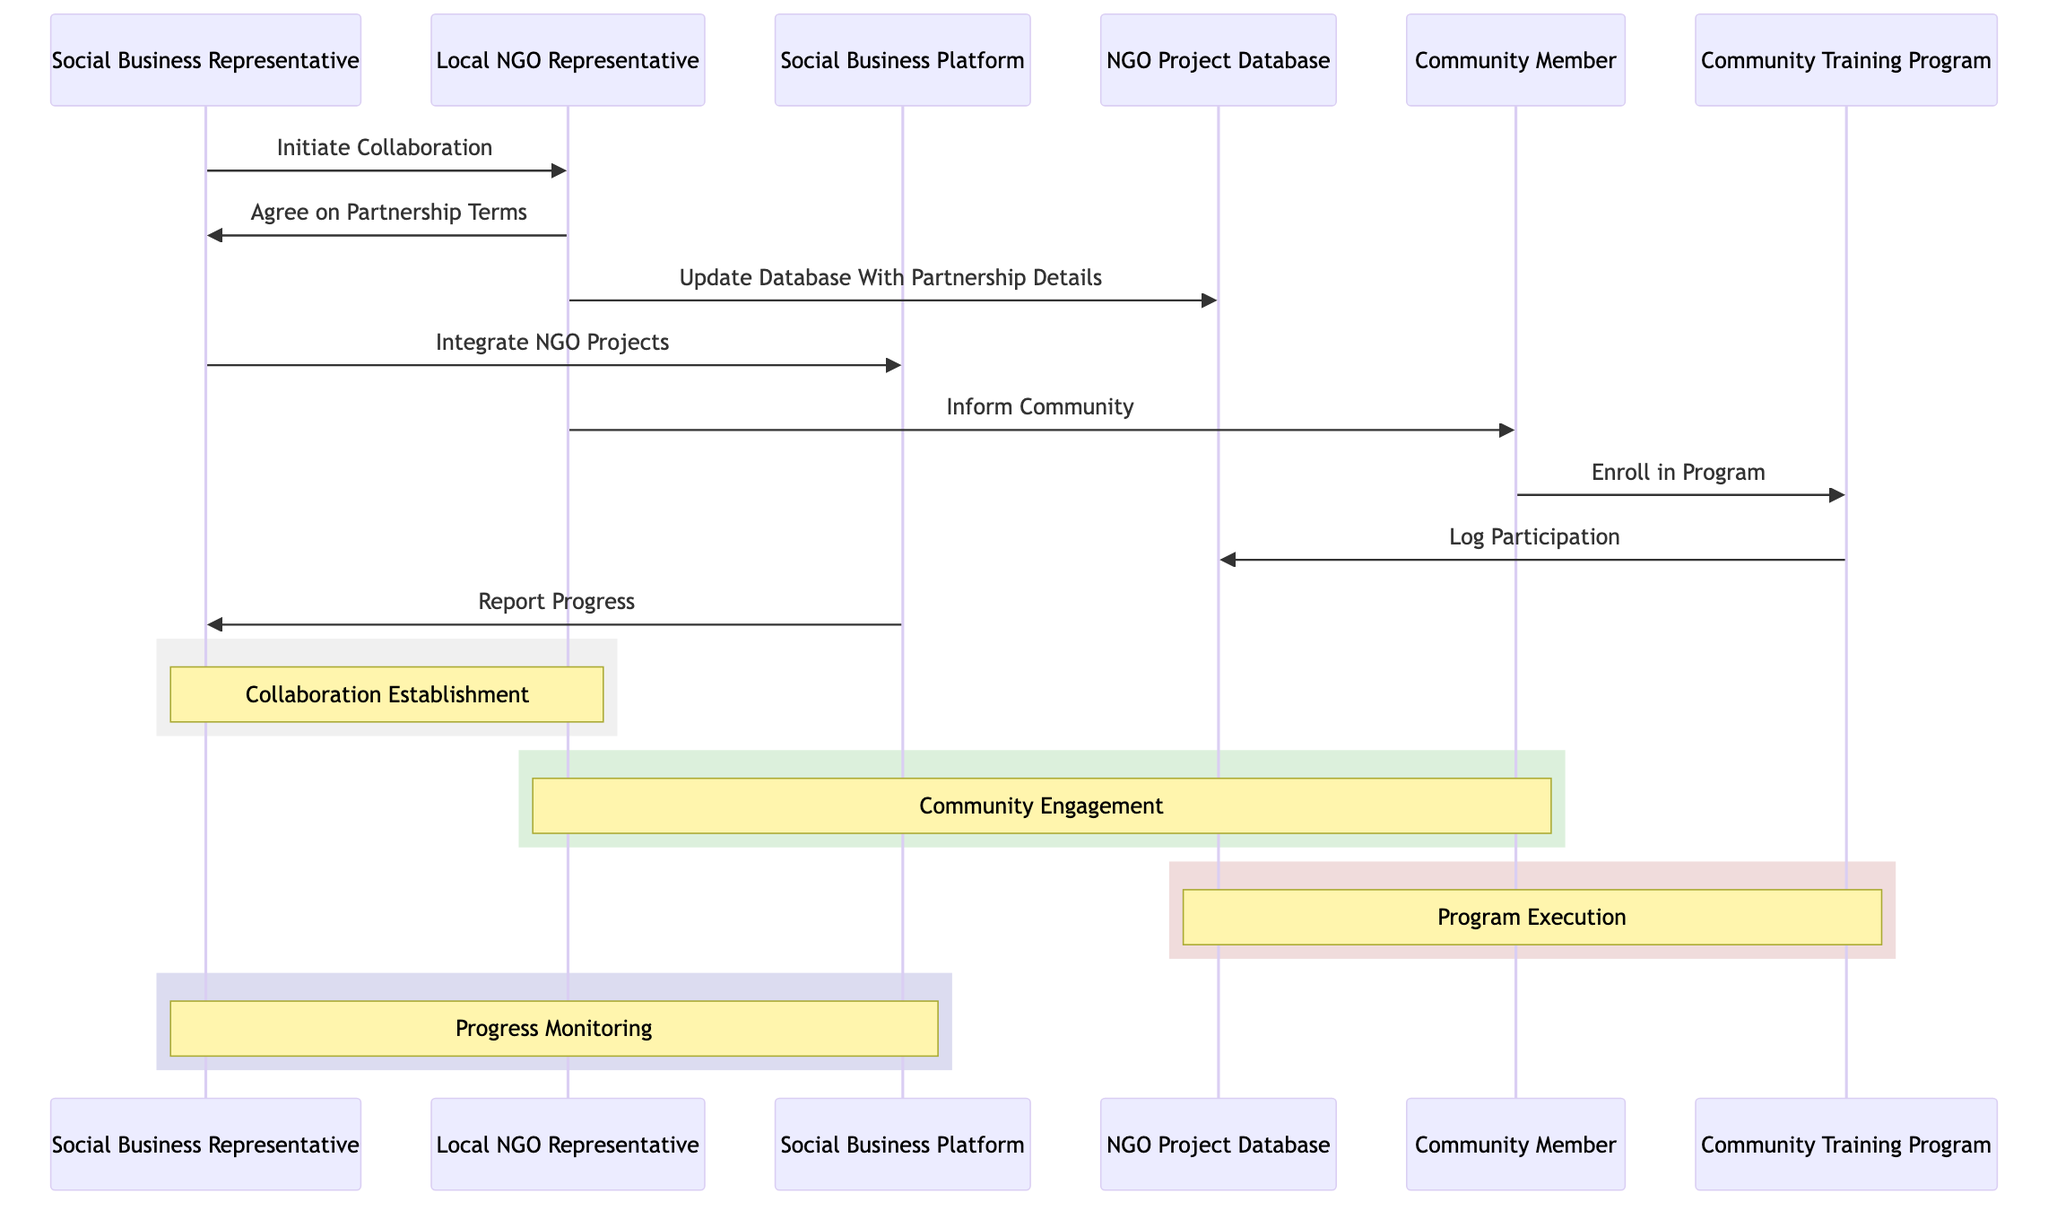What is the first message in the sequence? The first message is initiated by the Social Business Representative, who contacts the Local NGO Representative to discuss potential collaboration.
Answer: Initiate Collaboration How many participants are involved in the diagram? The diagram involves three participants: Social Business Representative, Local NGO Representative, and Community Member.
Answer: Three Which system does the Local NGO Representative update? The Local NGO Representative updates the NGO Project Database with the partnership details.
Answer: NGO Project Database What is the purpose of the message "Log Participation"? The purpose of the message "Log Participation" is to record the participation details of community members in the NGO's database after they enroll in the Community Training Program.
Answer: Log Participation What follows immediately after the NGO Representative informs the Community Member? After the NGO Representative informs the Community Member, the Community Member enrolls in the Community Training Program.
Answer: Enroll in Program What does the Social Business Platform generate for the Social Business Representative? The Social Business Platform generates reports on the progress of the collaboration for the Social Business Representative.
Answer: Report Progress How many notes are present in the diagram indicating different phases? There are four notes in the diagram, each indicating a different phase of the collaboration process.
Answer: Four Which actor receives the message "Agree on Partnership Terms"? The actor that receives the message "Agree on Partnership Terms" is the Social Business Representative from the Local NGO Representative.
Answer: Social Business Representative Which system is integrated into the Social Business Platform? The NGO projects are integrated into the Social Business Platform for better visibility.
Answer: NGO Projects 